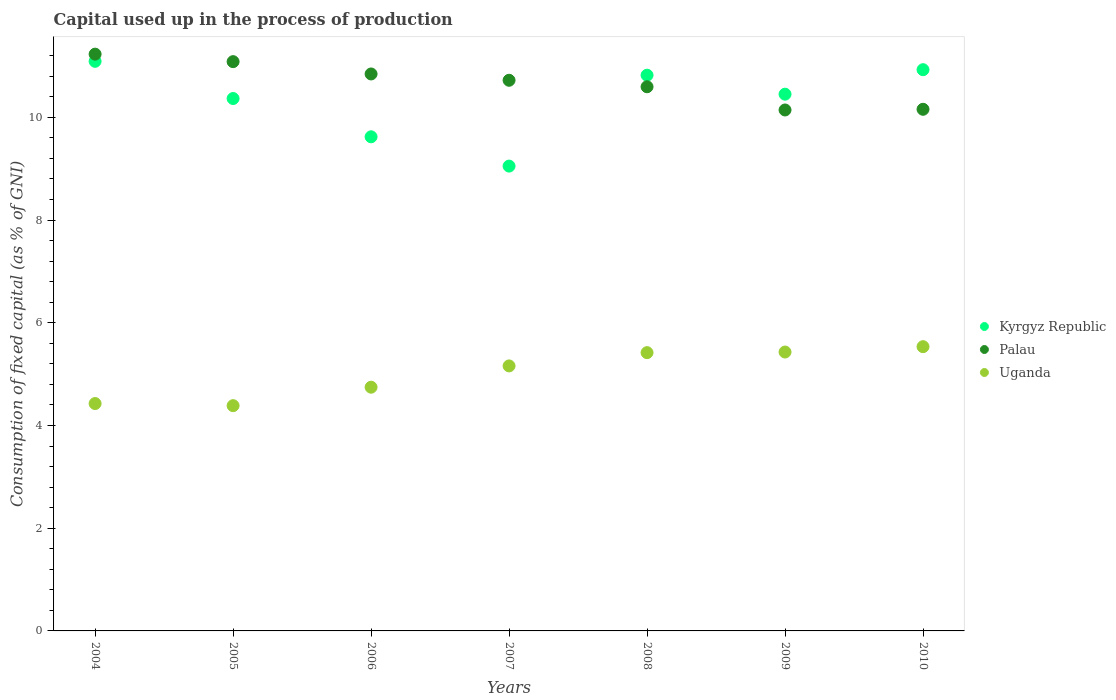How many different coloured dotlines are there?
Provide a short and direct response. 3. Is the number of dotlines equal to the number of legend labels?
Offer a very short reply. Yes. What is the capital used up in the process of production in Palau in 2010?
Provide a succinct answer. 10.16. Across all years, what is the maximum capital used up in the process of production in Kyrgyz Republic?
Your response must be concise. 11.09. Across all years, what is the minimum capital used up in the process of production in Kyrgyz Republic?
Your response must be concise. 9.05. In which year was the capital used up in the process of production in Palau minimum?
Provide a succinct answer. 2009. What is the total capital used up in the process of production in Palau in the graph?
Keep it short and to the point. 74.78. What is the difference between the capital used up in the process of production in Palau in 2004 and that in 2006?
Provide a short and direct response. 0.39. What is the difference between the capital used up in the process of production in Palau in 2007 and the capital used up in the process of production in Uganda in 2008?
Make the answer very short. 5.3. What is the average capital used up in the process of production in Kyrgyz Republic per year?
Offer a very short reply. 10.33. In the year 2008, what is the difference between the capital used up in the process of production in Uganda and capital used up in the process of production in Kyrgyz Republic?
Your answer should be very brief. -5.4. What is the ratio of the capital used up in the process of production in Kyrgyz Republic in 2008 to that in 2010?
Your response must be concise. 0.99. Is the capital used up in the process of production in Kyrgyz Republic in 2006 less than that in 2008?
Make the answer very short. Yes. Is the difference between the capital used up in the process of production in Uganda in 2004 and 2006 greater than the difference between the capital used up in the process of production in Kyrgyz Republic in 2004 and 2006?
Keep it short and to the point. No. What is the difference between the highest and the second highest capital used up in the process of production in Palau?
Give a very brief answer. 0.15. What is the difference between the highest and the lowest capital used up in the process of production in Uganda?
Make the answer very short. 1.15. Does the capital used up in the process of production in Kyrgyz Republic monotonically increase over the years?
Offer a terse response. No. Is the capital used up in the process of production in Uganda strictly less than the capital used up in the process of production in Kyrgyz Republic over the years?
Provide a succinct answer. Yes. How many dotlines are there?
Ensure brevity in your answer.  3. How many years are there in the graph?
Offer a very short reply. 7. What is the difference between two consecutive major ticks on the Y-axis?
Your response must be concise. 2. Are the values on the major ticks of Y-axis written in scientific E-notation?
Your answer should be very brief. No. Does the graph contain any zero values?
Give a very brief answer. No. Where does the legend appear in the graph?
Your answer should be very brief. Center right. How many legend labels are there?
Provide a short and direct response. 3. What is the title of the graph?
Make the answer very short. Capital used up in the process of production. What is the label or title of the Y-axis?
Your answer should be very brief. Consumption of fixed capital (as % of GNI). What is the Consumption of fixed capital (as % of GNI) in Kyrgyz Republic in 2004?
Provide a short and direct response. 11.09. What is the Consumption of fixed capital (as % of GNI) of Palau in 2004?
Ensure brevity in your answer.  11.23. What is the Consumption of fixed capital (as % of GNI) in Uganda in 2004?
Your answer should be very brief. 4.43. What is the Consumption of fixed capital (as % of GNI) in Kyrgyz Republic in 2005?
Provide a short and direct response. 10.37. What is the Consumption of fixed capital (as % of GNI) of Palau in 2005?
Offer a very short reply. 11.08. What is the Consumption of fixed capital (as % of GNI) in Uganda in 2005?
Ensure brevity in your answer.  4.39. What is the Consumption of fixed capital (as % of GNI) of Kyrgyz Republic in 2006?
Your answer should be compact. 9.62. What is the Consumption of fixed capital (as % of GNI) of Palau in 2006?
Offer a very short reply. 10.84. What is the Consumption of fixed capital (as % of GNI) in Uganda in 2006?
Keep it short and to the point. 4.75. What is the Consumption of fixed capital (as % of GNI) of Kyrgyz Republic in 2007?
Your answer should be compact. 9.05. What is the Consumption of fixed capital (as % of GNI) in Palau in 2007?
Your answer should be very brief. 10.72. What is the Consumption of fixed capital (as % of GNI) in Uganda in 2007?
Offer a very short reply. 5.16. What is the Consumption of fixed capital (as % of GNI) of Kyrgyz Republic in 2008?
Give a very brief answer. 10.82. What is the Consumption of fixed capital (as % of GNI) in Palau in 2008?
Ensure brevity in your answer.  10.6. What is the Consumption of fixed capital (as % of GNI) of Uganda in 2008?
Provide a short and direct response. 5.42. What is the Consumption of fixed capital (as % of GNI) in Kyrgyz Republic in 2009?
Your response must be concise. 10.45. What is the Consumption of fixed capital (as % of GNI) in Palau in 2009?
Ensure brevity in your answer.  10.14. What is the Consumption of fixed capital (as % of GNI) of Uganda in 2009?
Your response must be concise. 5.43. What is the Consumption of fixed capital (as % of GNI) in Kyrgyz Republic in 2010?
Provide a succinct answer. 10.93. What is the Consumption of fixed capital (as % of GNI) of Palau in 2010?
Your response must be concise. 10.16. What is the Consumption of fixed capital (as % of GNI) in Uganda in 2010?
Your answer should be compact. 5.53. Across all years, what is the maximum Consumption of fixed capital (as % of GNI) of Kyrgyz Republic?
Your answer should be compact. 11.09. Across all years, what is the maximum Consumption of fixed capital (as % of GNI) in Palau?
Your answer should be compact. 11.23. Across all years, what is the maximum Consumption of fixed capital (as % of GNI) of Uganda?
Make the answer very short. 5.53. Across all years, what is the minimum Consumption of fixed capital (as % of GNI) in Kyrgyz Republic?
Offer a terse response. 9.05. Across all years, what is the minimum Consumption of fixed capital (as % of GNI) in Palau?
Your answer should be very brief. 10.14. Across all years, what is the minimum Consumption of fixed capital (as % of GNI) in Uganda?
Ensure brevity in your answer.  4.39. What is the total Consumption of fixed capital (as % of GNI) in Kyrgyz Republic in the graph?
Offer a terse response. 72.33. What is the total Consumption of fixed capital (as % of GNI) in Palau in the graph?
Your response must be concise. 74.78. What is the total Consumption of fixed capital (as % of GNI) in Uganda in the graph?
Make the answer very short. 35.1. What is the difference between the Consumption of fixed capital (as % of GNI) in Kyrgyz Republic in 2004 and that in 2005?
Your response must be concise. 0.72. What is the difference between the Consumption of fixed capital (as % of GNI) in Palau in 2004 and that in 2005?
Give a very brief answer. 0.15. What is the difference between the Consumption of fixed capital (as % of GNI) of Uganda in 2004 and that in 2005?
Your answer should be compact. 0.04. What is the difference between the Consumption of fixed capital (as % of GNI) in Kyrgyz Republic in 2004 and that in 2006?
Offer a terse response. 1.47. What is the difference between the Consumption of fixed capital (as % of GNI) of Palau in 2004 and that in 2006?
Offer a terse response. 0.39. What is the difference between the Consumption of fixed capital (as % of GNI) of Uganda in 2004 and that in 2006?
Provide a short and direct response. -0.32. What is the difference between the Consumption of fixed capital (as % of GNI) of Kyrgyz Republic in 2004 and that in 2007?
Keep it short and to the point. 2.04. What is the difference between the Consumption of fixed capital (as % of GNI) in Palau in 2004 and that in 2007?
Provide a short and direct response. 0.51. What is the difference between the Consumption of fixed capital (as % of GNI) in Uganda in 2004 and that in 2007?
Provide a short and direct response. -0.73. What is the difference between the Consumption of fixed capital (as % of GNI) in Kyrgyz Republic in 2004 and that in 2008?
Your answer should be compact. 0.27. What is the difference between the Consumption of fixed capital (as % of GNI) of Palau in 2004 and that in 2008?
Your answer should be compact. 0.64. What is the difference between the Consumption of fixed capital (as % of GNI) of Uganda in 2004 and that in 2008?
Give a very brief answer. -0.99. What is the difference between the Consumption of fixed capital (as % of GNI) of Kyrgyz Republic in 2004 and that in 2009?
Provide a succinct answer. 0.64. What is the difference between the Consumption of fixed capital (as % of GNI) of Palau in 2004 and that in 2009?
Make the answer very short. 1.09. What is the difference between the Consumption of fixed capital (as % of GNI) of Uganda in 2004 and that in 2009?
Ensure brevity in your answer.  -1. What is the difference between the Consumption of fixed capital (as % of GNI) in Kyrgyz Republic in 2004 and that in 2010?
Provide a succinct answer. 0.16. What is the difference between the Consumption of fixed capital (as % of GNI) in Palau in 2004 and that in 2010?
Your answer should be compact. 1.07. What is the difference between the Consumption of fixed capital (as % of GNI) of Uganda in 2004 and that in 2010?
Make the answer very short. -1.11. What is the difference between the Consumption of fixed capital (as % of GNI) in Kyrgyz Republic in 2005 and that in 2006?
Ensure brevity in your answer.  0.75. What is the difference between the Consumption of fixed capital (as % of GNI) in Palau in 2005 and that in 2006?
Offer a very short reply. 0.24. What is the difference between the Consumption of fixed capital (as % of GNI) in Uganda in 2005 and that in 2006?
Your response must be concise. -0.36. What is the difference between the Consumption of fixed capital (as % of GNI) of Kyrgyz Republic in 2005 and that in 2007?
Offer a terse response. 1.32. What is the difference between the Consumption of fixed capital (as % of GNI) of Palau in 2005 and that in 2007?
Ensure brevity in your answer.  0.36. What is the difference between the Consumption of fixed capital (as % of GNI) in Uganda in 2005 and that in 2007?
Make the answer very short. -0.77. What is the difference between the Consumption of fixed capital (as % of GNI) in Kyrgyz Republic in 2005 and that in 2008?
Ensure brevity in your answer.  -0.45. What is the difference between the Consumption of fixed capital (as % of GNI) in Palau in 2005 and that in 2008?
Provide a short and direct response. 0.49. What is the difference between the Consumption of fixed capital (as % of GNI) of Uganda in 2005 and that in 2008?
Provide a short and direct response. -1.03. What is the difference between the Consumption of fixed capital (as % of GNI) of Kyrgyz Republic in 2005 and that in 2009?
Provide a short and direct response. -0.08. What is the difference between the Consumption of fixed capital (as % of GNI) in Palau in 2005 and that in 2009?
Offer a very short reply. 0.94. What is the difference between the Consumption of fixed capital (as % of GNI) in Uganda in 2005 and that in 2009?
Make the answer very short. -1.04. What is the difference between the Consumption of fixed capital (as % of GNI) in Kyrgyz Republic in 2005 and that in 2010?
Your response must be concise. -0.56. What is the difference between the Consumption of fixed capital (as % of GNI) of Palau in 2005 and that in 2010?
Offer a very short reply. 0.93. What is the difference between the Consumption of fixed capital (as % of GNI) of Uganda in 2005 and that in 2010?
Provide a short and direct response. -1.15. What is the difference between the Consumption of fixed capital (as % of GNI) of Kyrgyz Republic in 2006 and that in 2007?
Offer a very short reply. 0.57. What is the difference between the Consumption of fixed capital (as % of GNI) in Palau in 2006 and that in 2007?
Make the answer very short. 0.12. What is the difference between the Consumption of fixed capital (as % of GNI) of Uganda in 2006 and that in 2007?
Give a very brief answer. -0.41. What is the difference between the Consumption of fixed capital (as % of GNI) of Kyrgyz Republic in 2006 and that in 2008?
Give a very brief answer. -1.2. What is the difference between the Consumption of fixed capital (as % of GNI) of Palau in 2006 and that in 2008?
Your response must be concise. 0.25. What is the difference between the Consumption of fixed capital (as % of GNI) of Uganda in 2006 and that in 2008?
Provide a short and direct response. -0.67. What is the difference between the Consumption of fixed capital (as % of GNI) in Kyrgyz Republic in 2006 and that in 2009?
Make the answer very short. -0.83. What is the difference between the Consumption of fixed capital (as % of GNI) of Palau in 2006 and that in 2009?
Your response must be concise. 0.7. What is the difference between the Consumption of fixed capital (as % of GNI) of Uganda in 2006 and that in 2009?
Your response must be concise. -0.68. What is the difference between the Consumption of fixed capital (as % of GNI) of Kyrgyz Republic in 2006 and that in 2010?
Your response must be concise. -1.31. What is the difference between the Consumption of fixed capital (as % of GNI) of Palau in 2006 and that in 2010?
Make the answer very short. 0.69. What is the difference between the Consumption of fixed capital (as % of GNI) of Uganda in 2006 and that in 2010?
Give a very brief answer. -0.79. What is the difference between the Consumption of fixed capital (as % of GNI) of Kyrgyz Republic in 2007 and that in 2008?
Your answer should be very brief. -1.77. What is the difference between the Consumption of fixed capital (as % of GNI) in Palau in 2007 and that in 2008?
Your response must be concise. 0.13. What is the difference between the Consumption of fixed capital (as % of GNI) of Uganda in 2007 and that in 2008?
Provide a short and direct response. -0.26. What is the difference between the Consumption of fixed capital (as % of GNI) of Kyrgyz Republic in 2007 and that in 2009?
Make the answer very short. -1.4. What is the difference between the Consumption of fixed capital (as % of GNI) of Palau in 2007 and that in 2009?
Your answer should be very brief. 0.58. What is the difference between the Consumption of fixed capital (as % of GNI) in Uganda in 2007 and that in 2009?
Provide a short and direct response. -0.27. What is the difference between the Consumption of fixed capital (as % of GNI) of Kyrgyz Republic in 2007 and that in 2010?
Your answer should be compact. -1.88. What is the difference between the Consumption of fixed capital (as % of GNI) in Palau in 2007 and that in 2010?
Your answer should be compact. 0.56. What is the difference between the Consumption of fixed capital (as % of GNI) in Uganda in 2007 and that in 2010?
Your response must be concise. -0.37. What is the difference between the Consumption of fixed capital (as % of GNI) in Kyrgyz Republic in 2008 and that in 2009?
Your response must be concise. 0.37. What is the difference between the Consumption of fixed capital (as % of GNI) in Palau in 2008 and that in 2009?
Your response must be concise. 0.45. What is the difference between the Consumption of fixed capital (as % of GNI) of Uganda in 2008 and that in 2009?
Your answer should be compact. -0.01. What is the difference between the Consumption of fixed capital (as % of GNI) in Kyrgyz Republic in 2008 and that in 2010?
Your response must be concise. -0.11. What is the difference between the Consumption of fixed capital (as % of GNI) in Palau in 2008 and that in 2010?
Give a very brief answer. 0.44. What is the difference between the Consumption of fixed capital (as % of GNI) in Uganda in 2008 and that in 2010?
Give a very brief answer. -0.12. What is the difference between the Consumption of fixed capital (as % of GNI) in Kyrgyz Republic in 2009 and that in 2010?
Provide a short and direct response. -0.48. What is the difference between the Consumption of fixed capital (as % of GNI) of Palau in 2009 and that in 2010?
Ensure brevity in your answer.  -0.01. What is the difference between the Consumption of fixed capital (as % of GNI) in Uganda in 2009 and that in 2010?
Your response must be concise. -0.1. What is the difference between the Consumption of fixed capital (as % of GNI) in Kyrgyz Republic in 2004 and the Consumption of fixed capital (as % of GNI) in Palau in 2005?
Offer a very short reply. 0.01. What is the difference between the Consumption of fixed capital (as % of GNI) in Kyrgyz Republic in 2004 and the Consumption of fixed capital (as % of GNI) in Uganda in 2005?
Provide a succinct answer. 6.7. What is the difference between the Consumption of fixed capital (as % of GNI) of Palau in 2004 and the Consumption of fixed capital (as % of GNI) of Uganda in 2005?
Your answer should be very brief. 6.84. What is the difference between the Consumption of fixed capital (as % of GNI) in Kyrgyz Republic in 2004 and the Consumption of fixed capital (as % of GNI) in Palau in 2006?
Provide a succinct answer. 0.25. What is the difference between the Consumption of fixed capital (as % of GNI) of Kyrgyz Republic in 2004 and the Consumption of fixed capital (as % of GNI) of Uganda in 2006?
Ensure brevity in your answer.  6.35. What is the difference between the Consumption of fixed capital (as % of GNI) of Palau in 2004 and the Consumption of fixed capital (as % of GNI) of Uganda in 2006?
Ensure brevity in your answer.  6.48. What is the difference between the Consumption of fixed capital (as % of GNI) in Kyrgyz Republic in 2004 and the Consumption of fixed capital (as % of GNI) in Palau in 2007?
Provide a short and direct response. 0.37. What is the difference between the Consumption of fixed capital (as % of GNI) of Kyrgyz Republic in 2004 and the Consumption of fixed capital (as % of GNI) of Uganda in 2007?
Ensure brevity in your answer.  5.93. What is the difference between the Consumption of fixed capital (as % of GNI) of Palau in 2004 and the Consumption of fixed capital (as % of GNI) of Uganda in 2007?
Offer a terse response. 6.07. What is the difference between the Consumption of fixed capital (as % of GNI) in Kyrgyz Republic in 2004 and the Consumption of fixed capital (as % of GNI) in Palau in 2008?
Make the answer very short. 0.5. What is the difference between the Consumption of fixed capital (as % of GNI) in Kyrgyz Republic in 2004 and the Consumption of fixed capital (as % of GNI) in Uganda in 2008?
Make the answer very short. 5.67. What is the difference between the Consumption of fixed capital (as % of GNI) in Palau in 2004 and the Consumption of fixed capital (as % of GNI) in Uganda in 2008?
Provide a short and direct response. 5.81. What is the difference between the Consumption of fixed capital (as % of GNI) of Kyrgyz Republic in 2004 and the Consumption of fixed capital (as % of GNI) of Palau in 2009?
Ensure brevity in your answer.  0.95. What is the difference between the Consumption of fixed capital (as % of GNI) in Kyrgyz Republic in 2004 and the Consumption of fixed capital (as % of GNI) in Uganda in 2009?
Ensure brevity in your answer.  5.66. What is the difference between the Consumption of fixed capital (as % of GNI) in Kyrgyz Republic in 2004 and the Consumption of fixed capital (as % of GNI) in Palau in 2010?
Keep it short and to the point. 0.93. What is the difference between the Consumption of fixed capital (as % of GNI) in Kyrgyz Republic in 2004 and the Consumption of fixed capital (as % of GNI) in Uganda in 2010?
Offer a very short reply. 5.56. What is the difference between the Consumption of fixed capital (as % of GNI) of Palau in 2004 and the Consumption of fixed capital (as % of GNI) of Uganda in 2010?
Offer a terse response. 5.7. What is the difference between the Consumption of fixed capital (as % of GNI) of Kyrgyz Republic in 2005 and the Consumption of fixed capital (as % of GNI) of Palau in 2006?
Your answer should be very brief. -0.48. What is the difference between the Consumption of fixed capital (as % of GNI) of Kyrgyz Republic in 2005 and the Consumption of fixed capital (as % of GNI) of Uganda in 2006?
Your response must be concise. 5.62. What is the difference between the Consumption of fixed capital (as % of GNI) in Palau in 2005 and the Consumption of fixed capital (as % of GNI) in Uganda in 2006?
Provide a short and direct response. 6.34. What is the difference between the Consumption of fixed capital (as % of GNI) in Kyrgyz Republic in 2005 and the Consumption of fixed capital (as % of GNI) in Palau in 2007?
Provide a succinct answer. -0.36. What is the difference between the Consumption of fixed capital (as % of GNI) of Kyrgyz Republic in 2005 and the Consumption of fixed capital (as % of GNI) of Uganda in 2007?
Give a very brief answer. 5.21. What is the difference between the Consumption of fixed capital (as % of GNI) of Palau in 2005 and the Consumption of fixed capital (as % of GNI) of Uganda in 2007?
Provide a succinct answer. 5.92. What is the difference between the Consumption of fixed capital (as % of GNI) of Kyrgyz Republic in 2005 and the Consumption of fixed capital (as % of GNI) of Palau in 2008?
Give a very brief answer. -0.23. What is the difference between the Consumption of fixed capital (as % of GNI) of Kyrgyz Republic in 2005 and the Consumption of fixed capital (as % of GNI) of Uganda in 2008?
Provide a short and direct response. 4.95. What is the difference between the Consumption of fixed capital (as % of GNI) in Palau in 2005 and the Consumption of fixed capital (as % of GNI) in Uganda in 2008?
Keep it short and to the point. 5.67. What is the difference between the Consumption of fixed capital (as % of GNI) of Kyrgyz Republic in 2005 and the Consumption of fixed capital (as % of GNI) of Palau in 2009?
Your answer should be very brief. 0.22. What is the difference between the Consumption of fixed capital (as % of GNI) in Kyrgyz Republic in 2005 and the Consumption of fixed capital (as % of GNI) in Uganda in 2009?
Keep it short and to the point. 4.94. What is the difference between the Consumption of fixed capital (as % of GNI) in Palau in 2005 and the Consumption of fixed capital (as % of GNI) in Uganda in 2009?
Ensure brevity in your answer.  5.65. What is the difference between the Consumption of fixed capital (as % of GNI) in Kyrgyz Republic in 2005 and the Consumption of fixed capital (as % of GNI) in Palau in 2010?
Offer a terse response. 0.21. What is the difference between the Consumption of fixed capital (as % of GNI) of Kyrgyz Republic in 2005 and the Consumption of fixed capital (as % of GNI) of Uganda in 2010?
Your response must be concise. 4.83. What is the difference between the Consumption of fixed capital (as % of GNI) in Palau in 2005 and the Consumption of fixed capital (as % of GNI) in Uganda in 2010?
Your response must be concise. 5.55. What is the difference between the Consumption of fixed capital (as % of GNI) in Kyrgyz Republic in 2006 and the Consumption of fixed capital (as % of GNI) in Palau in 2007?
Your answer should be compact. -1.1. What is the difference between the Consumption of fixed capital (as % of GNI) of Kyrgyz Republic in 2006 and the Consumption of fixed capital (as % of GNI) of Uganda in 2007?
Ensure brevity in your answer.  4.46. What is the difference between the Consumption of fixed capital (as % of GNI) in Palau in 2006 and the Consumption of fixed capital (as % of GNI) in Uganda in 2007?
Provide a succinct answer. 5.68. What is the difference between the Consumption of fixed capital (as % of GNI) of Kyrgyz Republic in 2006 and the Consumption of fixed capital (as % of GNI) of Palau in 2008?
Ensure brevity in your answer.  -0.97. What is the difference between the Consumption of fixed capital (as % of GNI) in Kyrgyz Republic in 2006 and the Consumption of fixed capital (as % of GNI) in Uganda in 2008?
Your answer should be compact. 4.2. What is the difference between the Consumption of fixed capital (as % of GNI) in Palau in 2006 and the Consumption of fixed capital (as % of GNI) in Uganda in 2008?
Your answer should be very brief. 5.43. What is the difference between the Consumption of fixed capital (as % of GNI) in Kyrgyz Republic in 2006 and the Consumption of fixed capital (as % of GNI) in Palau in 2009?
Offer a very short reply. -0.52. What is the difference between the Consumption of fixed capital (as % of GNI) in Kyrgyz Republic in 2006 and the Consumption of fixed capital (as % of GNI) in Uganda in 2009?
Keep it short and to the point. 4.19. What is the difference between the Consumption of fixed capital (as % of GNI) of Palau in 2006 and the Consumption of fixed capital (as % of GNI) of Uganda in 2009?
Your response must be concise. 5.41. What is the difference between the Consumption of fixed capital (as % of GNI) in Kyrgyz Republic in 2006 and the Consumption of fixed capital (as % of GNI) in Palau in 2010?
Ensure brevity in your answer.  -0.54. What is the difference between the Consumption of fixed capital (as % of GNI) in Kyrgyz Republic in 2006 and the Consumption of fixed capital (as % of GNI) in Uganda in 2010?
Provide a succinct answer. 4.09. What is the difference between the Consumption of fixed capital (as % of GNI) in Palau in 2006 and the Consumption of fixed capital (as % of GNI) in Uganda in 2010?
Provide a succinct answer. 5.31. What is the difference between the Consumption of fixed capital (as % of GNI) in Kyrgyz Republic in 2007 and the Consumption of fixed capital (as % of GNI) in Palau in 2008?
Make the answer very short. -1.54. What is the difference between the Consumption of fixed capital (as % of GNI) of Kyrgyz Republic in 2007 and the Consumption of fixed capital (as % of GNI) of Uganda in 2008?
Your answer should be very brief. 3.63. What is the difference between the Consumption of fixed capital (as % of GNI) of Palau in 2007 and the Consumption of fixed capital (as % of GNI) of Uganda in 2008?
Keep it short and to the point. 5.3. What is the difference between the Consumption of fixed capital (as % of GNI) of Kyrgyz Republic in 2007 and the Consumption of fixed capital (as % of GNI) of Palau in 2009?
Provide a succinct answer. -1.09. What is the difference between the Consumption of fixed capital (as % of GNI) of Kyrgyz Republic in 2007 and the Consumption of fixed capital (as % of GNI) of Uganda in 2009?
Your answer should be very brief. 3.62. What is the difference between the Consumption of fixed capital (as % of GNI) in Palau in 2007 and the Consumption of fixed capital (as % of GNI) in Uganda in 2009?
Give a very brief answer. 5.29. What is the difference between the Consumption of fixed capital (as % of GNI) in Kyrgyz Republic in 2007 and the Consumption of fixed capital (as % of GNI) in Palau in 2010?
Your answer should be very brief. -1.11. What is the difference between the Consumption of fixed capital (as % of GNI) in Kyrgyz Republic in 2007 and the Consumption of fixed capital (as % of GNI) in Uganda in 2010?
Ensure brevity in your answer.  3.52. What is the difference between the Consumption of fixed capital (as % of GNI) of Palau in 2007 and the Consumption of fixed capital (as % of GNI) of Uganda in 2010?
Provide a succinct answer. 5.19. What is the difference between the Consumption of fixed capital (as % of GNI) in Kyrgyz Republic in 2008 and the Consumption of fixed capital (as % of GNI) in Palau in 2009?
Your answer should be very brief. 0.68. What is the difference between the Consumption of fixed capital (as % of GNI) of Kyrgyz Republic in 2008 and the Consumption of fixed capital (as % of GNI) of Uganda in 2009?
Your answer should be very brief. 5.39. What is the difference between the Consumption of fixed capital (as % of GNI) of Palau in 2008 and the Consumption of fixed capital (as % of GNI) of Uganda in 2009?
Your answer should be compact. 5.16. What is the difference between the Consumption of fixed capital (as % of GNI) of Kyrgyz Republic in 2008 and the Consumption of fixed capital (as % of GNI) of Palau in 2010?
Offer a terse response. 0.66. What is the difference between the Consumption of fixed capital (as % of GNI) in Kyrgyz Republic in 2008 and the Consumption of fixed capital (as % of GNI) in Uganda in 2010?
Your answer should be very brief. 5.29. What is the difference between the Consumption of fixed capital (as % of GNI) in Palau in 2008 and the Consumption of fixed capital (as % of GNI) in Uganda in 2010?
Keep it short and to the point. 5.06. What is the difference between the Consumption of fixed capital (as % of GNI) in Kyrgyz Republic in 2009 and the Consumption of fixed capital (as % of GNI) in Palau in 2010?
Provide a succinct answer. 0.29. What is the difference between the Consumption of fixed capital (as % of GNI) of Kyrgyz Republic in 2009 and the Consumption of fixed capital (as % of GNI) of Uganda in 2010?
Your response must be concise. 4.92. What is the difference between the Consumption of fixed capital (as % of GNI) in Palau in 2009 and the Consumption of fixed capital (as % of GNI) in Uganda in 2010?
Make the answer very short. 4.61. What is the average Consumption of fixed capital (as % of GNI) of Kyrgyz Republic per year?
Ensure brevity in your answer.  10.33. What is the average Consumption of fixed capital (as % of GNI) in Palau per year?
Offer a terse response. 10.68. What is the average Consumption of fixed capital (as % of GNI) of Uganda per year?
Your response must be concise. 5.01. In the year 2004, what is the difference between the Consumption of fixed capital (as % of GNI) of Kyrgyz Republic and Consumption of fixed capital (as % of GNI) of Palau?
Give a very brief answer. -0.14. In the year 2004, what is the difference between the Consumption of fixed capital (as % of GNI) of Kyrgyz Republic and Consumption of fixed capital (as % of GNI) of Uganda?
Keep it short and to the point. 6.66. In the year 2004, what is the difference between the Consumption of fixed capital (as % of GNI) in Palau and Consumption of fixed capital (as % of GNI) in Uganda?
Your response must be concise. 6.8. In the year 2005, what is the difference between the Consumption of fixed capital (as % of GNI) in Kyrgyz Republic and Consumption of fixed capital (as % of GNI) in Palau?
Your answer should be compact. -0.72. In the year 2005, what is the difference between the Consumption of fixed capital (as % of GNI) in Kyrgyz Republic and Consumption of fixed capital (as % of GNI) in Uganda?
Ensure brevity in your answer.  5.98. In the year 2005, what is the difference between the Consumption of fixed capital (as % of GNI) of Palau and Consumption of fixed capital (as % of GNI) of Uganda?
Provide a short and direct response. 6.7. In the year 2006, what is the difference between the Consumption of fixed capital (as % of GNI) in Kyrgyz Republic and Consumption of fixed capital (as % of GNI) in Palau?
Offer a very short reply. -1.22. In the year 2006, what is the difference between the Consumption of fixed capital (as % of GNI) of Kyrgyz Republic and Consumption of fixed capital (as % of GNI) of Uganda?
Make the answer very short. 4.88. In the year 2006, what is the difference between the Consumption of fixed capital (as % of GNI) of Palau and Consumption of fixed capital (as % of GNI) of Uganda?
Your response must be concise. 6.1. In the year 2007, what is the difference between the Consumption of fixed capital (as % of GNI) in Kyrgyz Republic and Consumption of fixed capital (as % of GNI) in Palau?
Your answer should be very brief. -1.67. In the year 2007, what is the difference between the Consumption of fixed capital (as % of GNI) of Kyrgyz Republic and Consumption of fixed capital (as % of GNI) of Uganda?
Your response must be concise. 3.89. In the year 2007, what is the difference between the Consumption of fixed capital (as % of GNI) in Palau and Consumption of fixed capital (as % of GNI) in Uganda?
Provide a short and direct response. 5.56. In the year 2008, what is the difference between the Consumption of fixed capital (as % of GNI) of Kyrgyz Republic and Consumption of fixed capital (as % of GNI) of Palau?
Your answer should be very brief. 0.23. In the year 2008, what is the difference between the Consumption of fixed capital (as % of GNI) of Kyrgyz Republic and Consumption of fixed capital (as % of GNI) of Uganda?
Ensure brevity in your answer.  5.4. In the year 2008, what is the difference between the Consumption of fixed capital (as % of GNI) of Palau and Consumption of fixed capital (as % of GNI) of Uganda?
Your answer should be very brief. 5.18. In the year 2009, what is the difference between the Consumption of fixed capital (as % of GNI) in Kyrgyz Republic and Consumption of fixed capital (as % of GNI) in Palau?
Give a very brief answer. 0.31. In the year 2009, what is the difference between the Consumption of fixed capital (as % of GNI) of Kyrgyz Republic and Consumption of fixed capital (as % of GNI) of Uganda?
Ensure brevity in your answer.  5.02. In the year 2009, what is the difference between the Consumption of fixed capital (as % of GNI) in Palau and Consumption of fixed capital (as % of GNI) in Uganda?
Your response must be concise. 4.71. In the year 2010, what is the difference between the Consumption of fixed capital (as % of GNI) of Kyrgyz Republic and Consumption of fixed capital (as % of GNI) of Palau?
Provide a succinct answer. 0.77. In the year 2010, what is the difference between the Consumption of fixed capital (as % of GNI) of Kyrgyz Republic and Consumption of fixed capital (as % of GNI) of Uganda?
Provide a short and direct response. 5.39. In the year 2010, what is the difference between the Consumption of fixed capital (as % of GNI) of Palau and Consumption of fixed capital (as % of GNI) of Uganda?
Your response must be concise. 4.62. What is the ratio of the Consumption of fixed capital (as % of GNI) of Kyrgyz Republic in 2004 to that in 2005?
Your response must be concise. 1.07. What is the ratio of the Consumption of fixed capital (as % of GNI) of Palau in 2004 to that in 2005?
Your response must be concise. 1.01. What is the ratio of the Consumption of fixed capital (as % of GNI) in Uganda in 2004 to that in 2005?
Ensure brevity in your answer.  1.01. What is the ratio of the Consumption of fixed capital (as % of GNI) of Kyrgyz Republic in 2004 to that in 2006?
Ensure brevity in your answer.  1.15. What is the ratio of the Consumption of fixed capital (as % of GNI) of Palau in 2004 to that in 2006?
Give a very brief answer. 1.04. What is the ratio of the Consumption of fixed capital (as % of GNI) in Uganda in 2004 to that in 2006?
Provide a short and direct response. 0.93. What is the ratio of the Consumption of fixed capital (as % of GNI) of Kyrgyz Republic in 2004 to that in 2007?
Offer a terse response. 1.23. What is the ratio of the Consumption of fixed capital (as % of GNI) in Palau in 2004 to that in 2007?
Give a very brief answer. 1.05. What is the ratio of the Consumption of fixed capital (as % of GNI) of Uganda in 2004 to that in 2007?
Give a very brief answer. 0.86. What is the ratio of the Consumption of fixed capital (as % of GNI) in Kyrgyz Republic in 2004 to that in 2008?
Provide a short and direct response. 1.02. What is the ratio of the Consumption of fixed capital (as % of GNI) of Palau in 2004 to that in 2008?
Provide a short and direct response. 1.06. What is the ratio of the Consumption of fixed capital (as % of GNI) of Uganda in 2004 to that in 2008?
Your response must be concise. 0.82. What is the ratio of the Consumption of fixed capital (as % of GNI) of Kyrgyz Republic in 2004 to that in 2009?
Keep it short and to the point. 1.06. What is the ratio of the Consumption of fixed capital (as % of GNI) in Palau in 2004 to that in 2009?
Provide a short and direct response. 1.11. What is the ratio of the Consumption of fixed capital (as % of GNI) in Uganda in 2004 to that in 2009?
Provide a short and direct response. 0.82. What is the ratio of the Consumption of fixed capital (as % of GNI) of Kyrgyz Republic in 2004 to that in 2010?
Provide a succinct answer. 1.01. What is the ratio of the Consumption of fixed capital (as % of GNI) of Palau in 2004 to that in 2010?
Give a very brief answer. 1.11. What is the ratio of the Consumption of fixed capital (as % of GNI) in Uganda in 2004 to that in 2010?
Keep it short and to the point. 0.8. What is the ratio of the Consumption of fixed capital (as % of GNI) in Kyrgyz Republic in 2005 to that in 2006?
Give a very brief answer. 1.08. What is the ratio of the Consumption of fixed capital (as % of GNI) in Palau in 2005 to that in 2006?
Offer a very short reply. 1.02. What is the ratio of the Consumption of fixed capital (as % of GNI) in Uganda in 2005 to that in 2006?
Give a very brief answer. 0.92. What is the ratio of the Consumption of fixed capital (as % of GNI) of Kyrgyz Republic in 2005 to that in 2007?
Provide a succinct answer. 1.15. What is the ratio of the Consumption of fixed capital (as % of GNI) of Palau in 2005 to that in 2007?
Ensure brevity in your answer.  1.03. What is the ratio of the Consumption of fixed capital (as % of GNI) in Uganda in 2005 to that in 2007?
Provide a succinct answer. 0.85. What is the ratio of the Consumption of fixed capital (as % of GNI) in Kyrgyz Republic in 2005 to that in 2008?
Your answer should be very brief. 0.96. What is the ratio of the Consumption of fixed capital (as % of GNI) of Palau in 2005 to that in 2008?
Make the answer very short. 1.05. What is the ratio of the Consumption of fixed capital (as % of GNI) in Uganda in 2005 to that in 2008?
Provide a short and direct response. 0.81. What is the ratio of the Consumption of fixed capital (as % of GNI) of Palau in 2005 to that in 2009?
Give a very brief answer. 1.09. What is the ratio of the Consumption of fixed capital (as % of GNI) of Uganda in 2005 to that in 2009?
Offer a terse response. 0.81. What is the ratio of the Consumption of fixed capital (as % of GNI) in Kyrgyz Republic in 2005 to that in 2010?
Provide a short and direct response. 0.95. What is the ratio of the Consumption of fixed capital (as % of GNI) of Palau in 2005 to that in 2010?
Keep it short and to the point. 1.09. What is the ratio of the Consumption of fixed capital (as % of GNI) of Uganda in 2005 to that in 2010?
Provide a succinct answer. 0.79. What is the ratio of the Consumption of fixed capital (as % of GNI) in Kyrgyz Republic in 2006 to that in 2007?
Give a very brief answer. 1.06. What is the ratio of the Consumption of fixed capital (as % of GNI) in Palau in 2006 to that in 2007?
Make the answer very short. 1.01. What is the ratio of the Consumption of fixed capital (as % of GNI) of Uganda in 2006 to that in 2007?
Provide a succinct answer. 0.92. What is the ratio of the Consumption of fixed capital (as % of GNI) in Kyrgyz Republic in 2006 to that in 2008?
Provide a short and direct response. 0.89. What is the ratio of the Consumption of fixed capital (as % of GNI) of Palau in 2006 to that in 2008?
Offer a terse response. 1.02. What is the ratio of the Consumption of fixed capital (as % of GNI) in Uganda in 2006 to that in 2008?
Offer a terse response. 0.88. What is the ratio of the Consumption of fixed capital (as % of GNI) in Kyrgyz Republic in 2006 to that in 2009?
Give a very brief answer. 0.92. What is the ratio of the Consumption of fixed capital (as % of GNI) in Palau in 2006 to that in 2009?
Offer a terse response. 1.07. What is the ratio of the Consumption of fixed capital (as % of GNI) in Uganda in 2006 to that in 2009?
Provide a succinct answer. 0.87. What is the ratio of the Consumption of fixed capital (as % of GNI) in Kyrgyz Republic in 2006 to that in 2010?
Keep it short and to the point. 0.88. What is the ratio of the Consumption of fixed capital (as % of GNI) of Palau in 2006 to that in 2010?
Your answer should be compact. 1.07. What is the ratio of the Consumption of fixed capital (as % of GNI) of Uganda in 2006 to that in 2010?
Make the answer very short. 0.86. What is the ratio of the Consumption of fixed capital (as % of GNI) in Kyrgyz Republic in 2007 to that in 2008?
Your response must be concise. 0.84. What is the ratio of the Consumption of fixed capital (as % of GNI) of Palau in 2007 to that in 2008?
Keep it short and to the point. 1.01. What is the ratio of the Consumption of fixed capital (as % of GNI) of Uganda in 2007 to that in 2008?
Keep it short and to the point. 0.95. What is the ratio of the Consumption of fixed capital (as % of GNI) in Kyrgyz Republic in 2007 to that in 2009?
Provide a short and direct response. 0.87. What is the ratio of the Consumption of fixed capital (as % of GNI) in Palau in 2007 to that in 2009?
Offer a very short reply. 1.06. What is the ratio of the Consumption of fixed capital (as % of GNI) of Uganda in 2007 to that in 2009?
Your response must be concise. 0.95. What is the ratio of the Consumption of fixed capital (as % of GNI) in Kyrgyz Republic in 2007 to that in 2010?
Your response must be concise. 0.83. What is the ratio of the Consumption of fixed capital (as % of GNI) in Palau in 2007 to that in 2010?
Your answer should be very brief. 1.06. What is the ratio of the Consumption of fixed capital (as % of GNI) in Uganda in 2007 to that in 2010?
Provide a succinct answer. 0.93. What is the ratio of the Consumption of fixed capital (as % of GNI) of Kyrgyz Republic in 2008 to that in 2009?
Make the answer very short. 1.04. What is the ratio of the Consumption of fixed capital (as % of GNI) of Palau in 2008 to that in 2009?
Give a very brief answer. 1.04. What is the ratio of the Consumption of fixed capital (as % of GNI) of Uganda in 2008 to that in 2009?
Your response must be concise. 1. What is the ratio of the Consumption of fixed capital (as % of GNI) in Kyrgyz Republic in 2008 to that in 2010?
Make the answer very short. 0.99. What is the ratio of the Consumption of fixed capital (as % of GNI) of Palau in 2008 to that in 2010?
Your response must be concise. 1.04. What is the ratio of the Consumption of fixed capital (as % of GNI) of Uganda in 2008 to that in 2010?
Your answer should be very brief. 0.98. What is the ratio of the Consumption of fixed capital (as % of GNI) in Kyrgyz Republic in 2009 to that in 2010?
Offer a terse response. 0.96. What is the ratio of the Consumption of fixed capital (as % of GNI) of Uganda in 2009 to that in 2010?
Offer a very short reply. 0.98. What is the difference between the highest and the second highest Consumption of fixed capital (as % of GNI) in Kyrgyz Republic?
Offer a very short reply. 0.16. What is the difference between the highest and the second highest Consumption of fixed capital (as % of GNI) in Palau?
Give a very brief answer. 0.15. What is the difference between the highest and the second highest Consumption of fixed capital (as % of GNI) of Uganda?
Your response must be concise. 0.1. What is the difference between the highest and the lowest Consumption of fixed capital (as % of GNI) of Kyrgyz Republic?
Provide a succinct answer. 2.04. What is the difference between the highest and the lowest Consumption of fixed capital (as % of GNI) of Palau?
Offer a very short reply. 1.09. What is the difference between the highest and the lowest Consumption of fixed capital (as % of GNI) of Uganda?
Offer a very short reply. 1.15. 